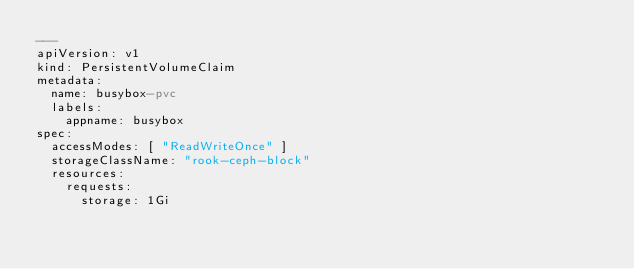<code> <loc_0><loc_0><loc_500><loc_500><_YAML_>---
apiVersion: v1
kind: PersistentVolumeClaim
metadata:
  name: busybox-pvc
  labels:
    appname: busybox
spec:
  accessModes: [ "ReadWriteOnce" ]
  storageClassName: "rook-ceph-block"
  resources:
    requests:
      storage: 1Gi
</code> 